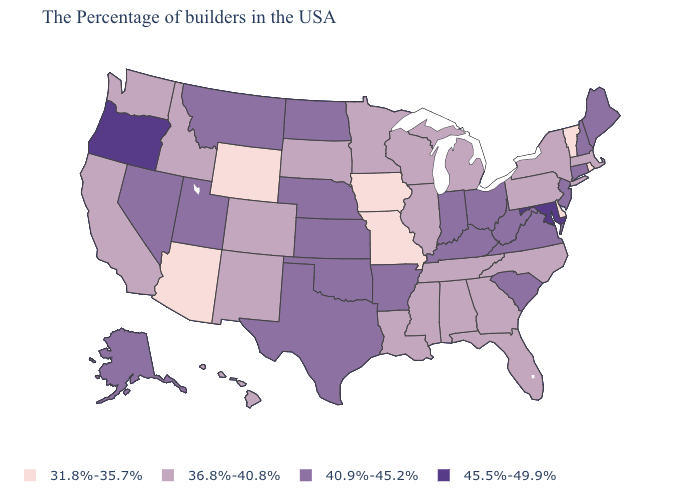Name the states that have a value in the range 45.5%-49.9%?
Give a very brief answer. Maryland, Oregon. Among the states that border Utah , which have the lowest value?
Be succinct. Wyoming, Arizona. Name the states that have a value in the range 36.8%-40.8%?
Concise answer only. Massachusetts, New York, Pennsylvania, North Carolina, Florida, Georgia, Michigan, Alabama, Tennessee, Wisconsin, Illinois, Mississippi, Louisiana, Minnesota, South Dakota, Colorado, New Mexico, Idaho, California, Washington, Hawaii. How many symbols are there in the legend?
Be succinct. 4. What is the value of Pennsylvania?
Keep it brief. 36.8%-40.8%. Does Pennsylvania have the highest value in the Northeast?
Give a very brief answer. No. Name the states that have a value in the range 36.8%-40.8%?
Give a very brief answer. Massachusetts, New York, Pennsylvania, North Carolina, Florida, Georgia, Michigan, Alabama, Tennessee, Wisconsin, Illinois, Mississippi, Louisiana, Minnesota, South Dakota, Colorado, New Mexico, Idaho, California, Washington, Hawaii. Is the legend a continuous bar?
Quick response, please. No. What is the value of New York?
Answer briefly. 36.8%-40.8%. Name the states that have a value in the range 40.9%-45.2%?
Short answer required. Maine, New Hampshire, Connecticut, New Jersey, Virginia, South Carolina, West Virginia, Ohio, Kentucky, Indiana, Arkansas, Kansas, Nebraska, Oklahoma, Texas, North Dakota, Utah, Montana, Nevada, Alaska. Name the states that have a value in the range 31.8%-35.7%?
Keep it brief. Rhode Island, Vermont, Delaware, Missouri, Iowa, Wyoming, Arizona. Does the map have missing data?
Keep it brief. No. Does Idaho have the lowest value in the West?
Write a very short answer. No. What is the value of Alaska?
Be succinct. 40.9%-45.2%. Does the map have missing data?
Quick response, please. No. 